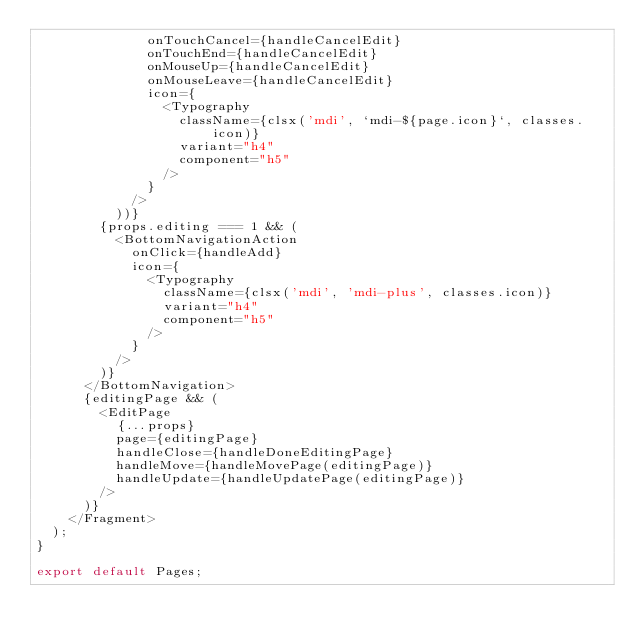<code> <loc_0><loc_0><loc_500><loc_500><_TypeScript_>              onTouchCancel={handleCancelEdit}
              onTouchEnd={handleCancelEdit}
              onMouseUp={handleCancelEdit}
              onMouseLeave={handleCancelEdit}
              icon={
                <Typography
                  className={clsx('mdi', `mdi-${page.icon}`, classes.icon)}
                  variant="h4"
                  component="h5"
                />
              }
            />
          ))}
        {props.editing === 1 && (
          <BottomNavigationAction
            onClick={handleAdd}
            icon={
              <Typography
                className={clsx('mdi', 'mdi-plus', classes.icon)}
                variant="h4"
                component="h5"
              />
            }
          />
        )}
      </BottomNavigation>
      {editingPage && (
        <EditPage
          {...props}
          page={editingPage}
          handleClose={handleDoneEditingPage}
          handleMove={handleMovePage(editingPage)}
          handleUpdate={handleUpdatePage(editingPage)}
        />
      )}
    </Fragment>
  );
}

export default Pages;
</code> 